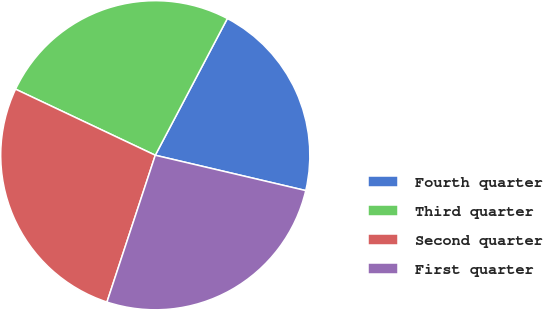<chart> <loc_0><loc_0><loc_500><loc_500><pie_chart><fcel>Fourth quarter<fcel>Third quarter<fcel>Second quarter<fcel>First quarter<nl><fcel>20.95%<fcel>25.69%<fcel>26.97%<fcel>26.39%<nl></chart> 